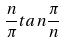<formula> <loc_0><loc_0><loc_500><loc_500>\frac { n } { \pi } t a n \frac { \pi } { n }</formula> 